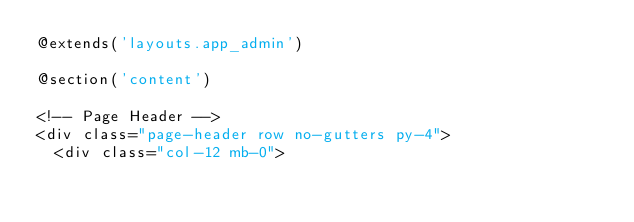<code> <loc_0><loc_0><loc_500><loc_500><_PHP_>@extends('layouts.app_admin')

@section('content')    

<!-- Page Header -->
<div class="page-header row no-gutters py-4">
  <div class="col-12 mb-0"></code> 